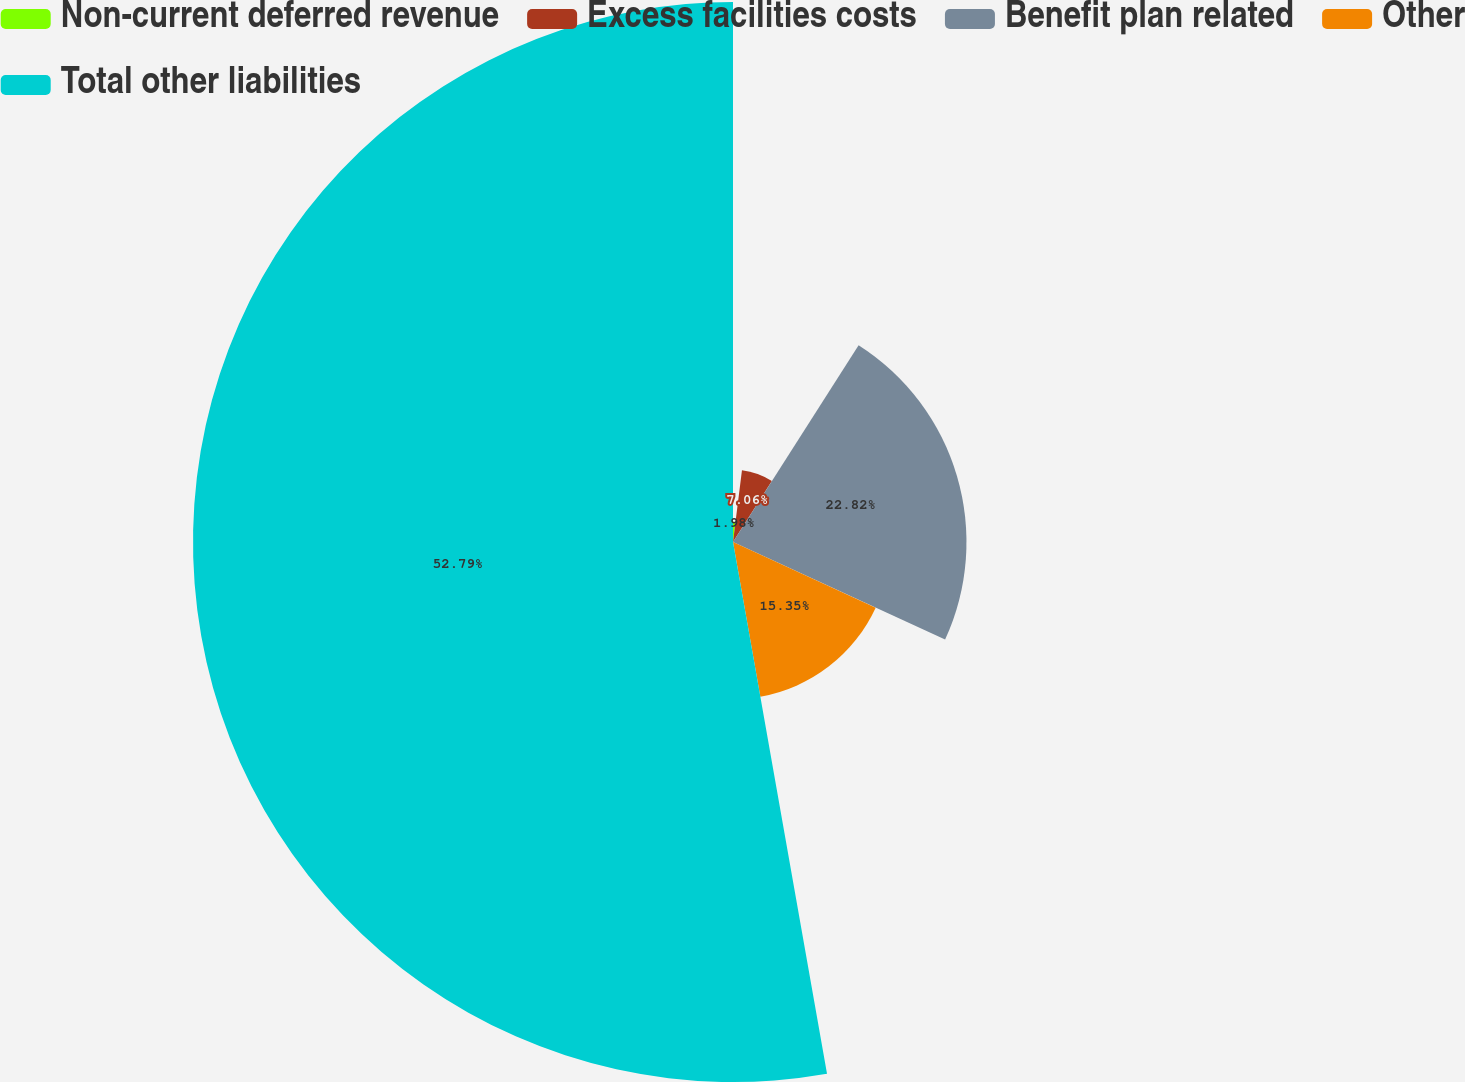Convert chart. <chart><loc_0><loc_0><loc_500><loc_500><pie_chart><fcel>Non-current deferred revenue<fcel>Excess facilities costs<fcel>Benefit plan related<fcel>Other<fcel>Total other liabilities<nl><fcel>1.98%<fcel>7.06%<fcel>22.82%<fcel>15.35%<fcel>52.78%<nl></chart> 